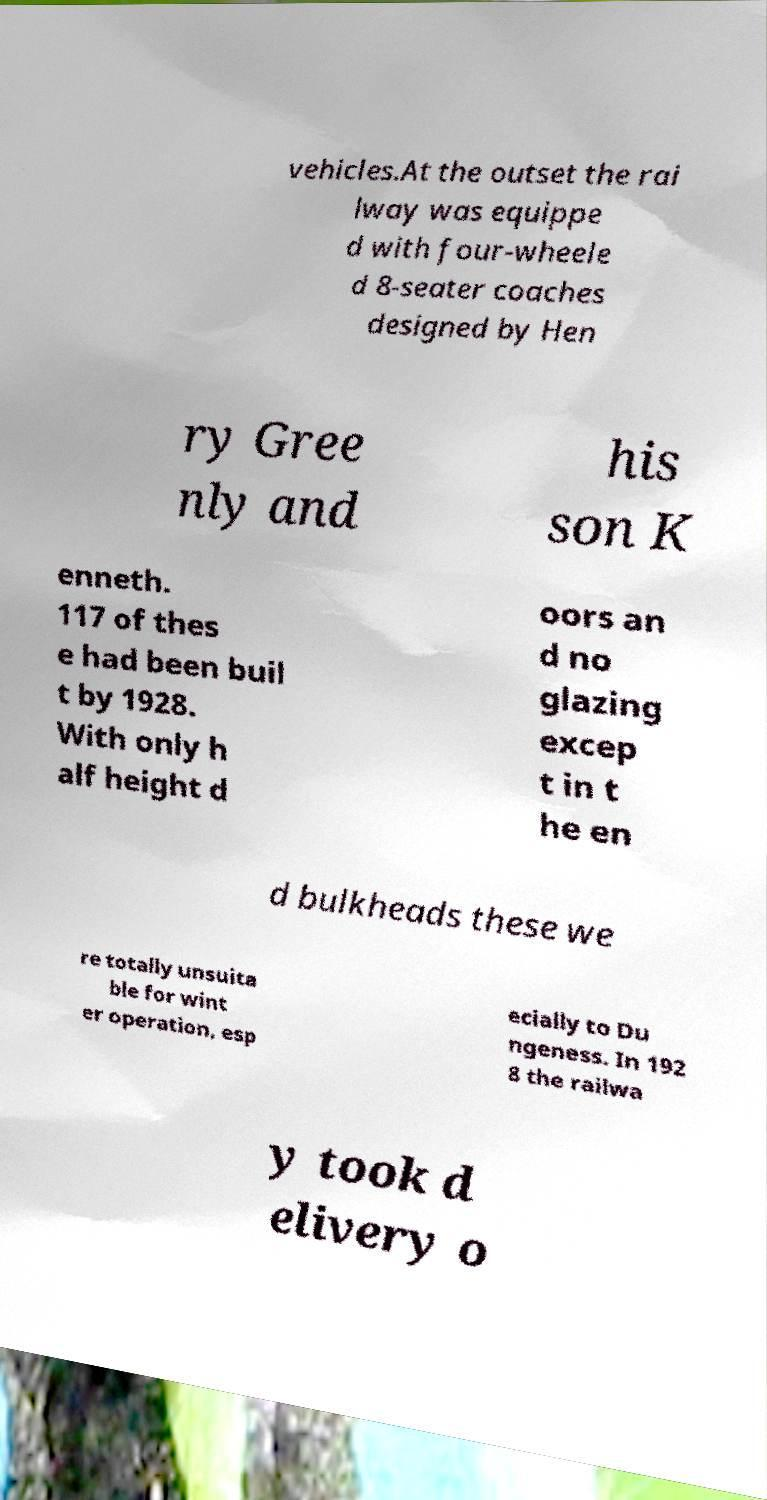Please identify and transcribe the text found in this image. vehicles.At the outset the rai lway was equippe d with four-wheele d 8-seater coaches designed by Hen ry Gree nly and his son K enneth. 117 of thes e had been buil t by 1928. With only h alf height d oors an d no glazing excep t in t he en d bulkheads these we re totally unsuita ble for wint er operation, esp ecially to Du ngeness. In 192 8 the railwa y took d elivery o 